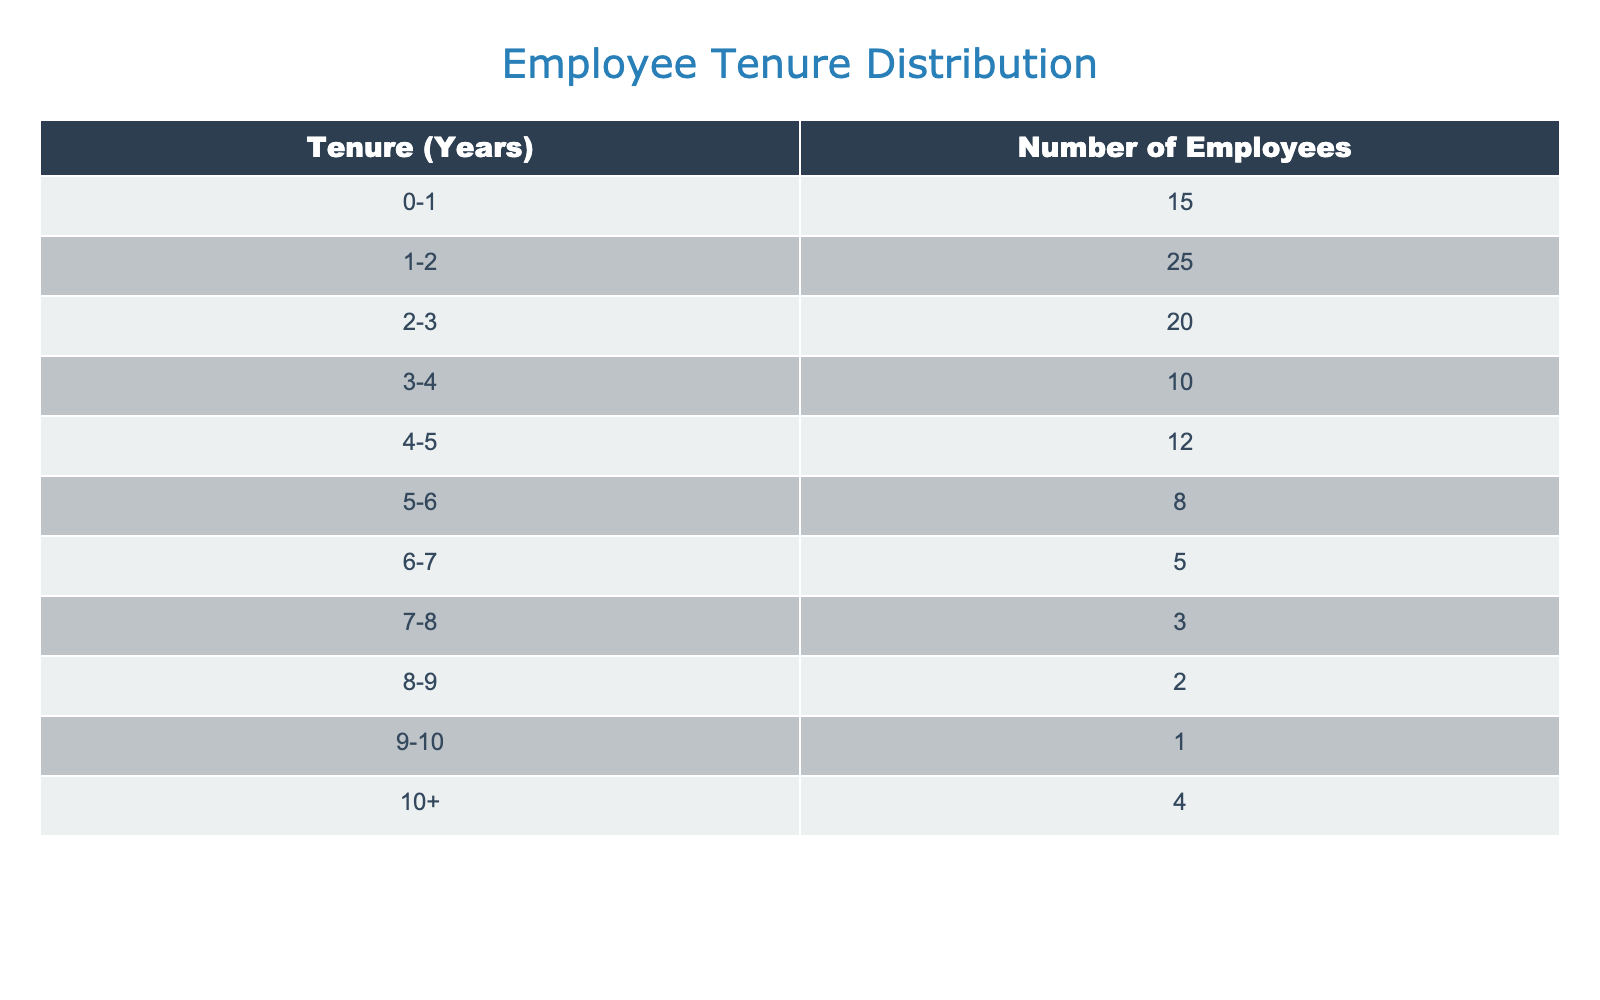What is the number of employees with a tenure of 0-1 years? The table shows that there are 15 employees who have a tenure of 0-1 years.
Answer: 15 What is the total number of employees with a tenure of 5-10 years? To find this, we need to add the number of employees in the ranges 5-6 (8), 6-7 (5), 7-8 (3), 8-9 (2), 9-10 (1), and 10+ (4). The total is 8 + 5 + 3 + 2 + 1 + 4 = 23.
Answer: 23 Is there any employee with a tenure of 9-10 years? The table indicates that there is 1 employee with a tenure of 9-10 years.
Answer: Yes How many employees have a tenure of less than 3 years? To find this, we need to add the number of employees in the ranges 0-1 (15), 1-2 (25), and 2-3 (20). The total is 15 + 25 + 20 = 60.
Answer: 60 What is the median tenure range of employees in this firm? To find the median, we first list out the number of employees cumulatively: 15 (0-1), 40 (1-2), 60 (2-3), 70 (3-4), 82 (4-5), 90 (5-6), 95 (6-7), 98 (7-8), 100 (8-9), 101 (9-10), 105 (10+). The total number of employees is 105, so the median is at the position 53 (middle of 105). This falls in the 2-3 year tenure range since it is between 40 and 60.
Answer: 2-3 years What percentage of employees have a tenure of 10 years or more? There are 4 employees with a tenure of 10+ years out of a total of 105 employees. To find the percentage, we divide 4 by 105 and then multiply by 100. This gives us (4/105) * 100 ≈ 3.81%.
Answer: Approximately 3.81% 